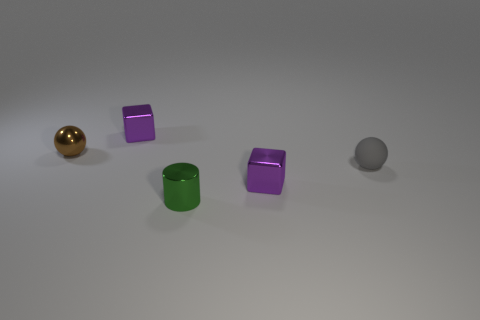Add 2 gray things. How many objects exist? 7 Subtract all balls. How many objects are left? 3 Add 4 brown metallic balls. How many brown metallic balls exist? 5 Subtract 0 yellow blocks. How many objects are left? 5 Subtract all blue shiny cylinders. Subtract all tiny green cylinders. How many objects are left? 4 Add 3 tiny matte things. How many tiny matte things are left? 4 